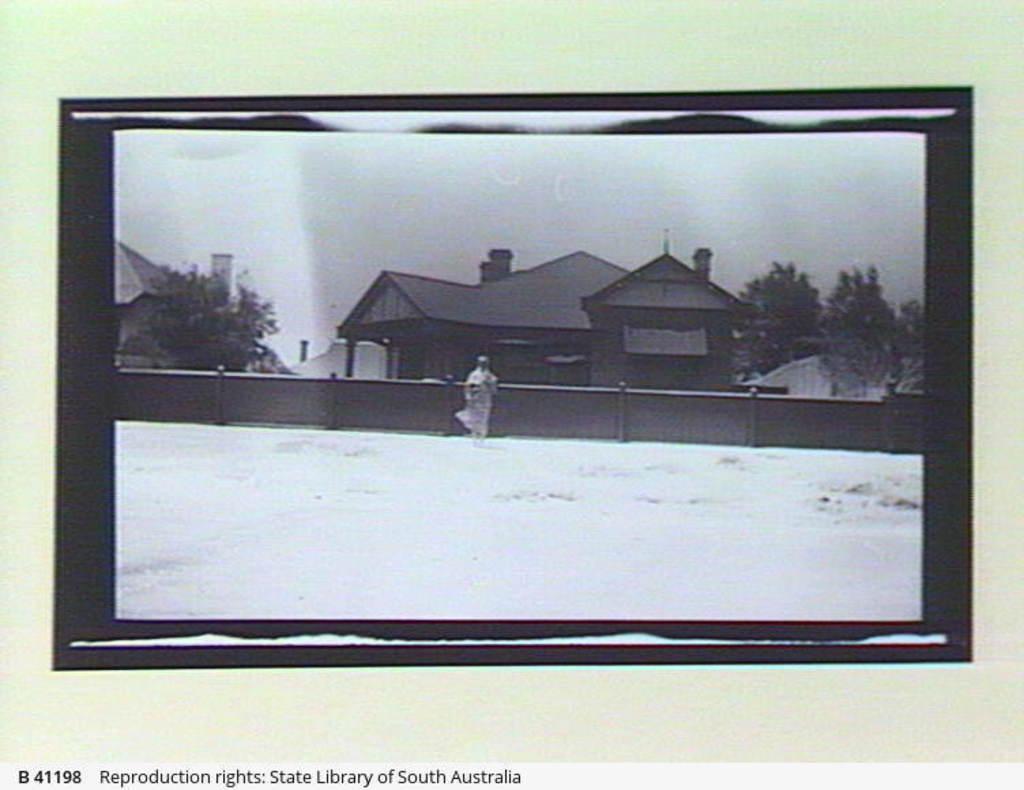What is the color scheme of the image? The image is black and white. Who is present in the image? There is a woman in the image. What can be seen in the background of the image? There is a wall, trees, and houses in the background of the image. Is there any text present in the image? Yes, there is text written at the bottom of the image. What type of ice can be seen melting in the field in the image? There is no ice or field present in the image; it is a black and white image featuring a woman, a wall, trees, houses, and text. 